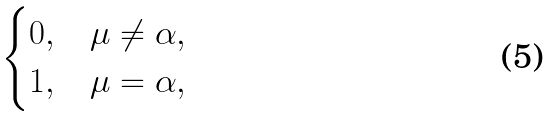Convert formula to latex. <formula><loc_0><loc_0><loc_500><loc_500>\begin{cases} 0 , & \mu \ne \alpha , \\ 1 , & \mu = \alpha , \end{cases}</formula> 